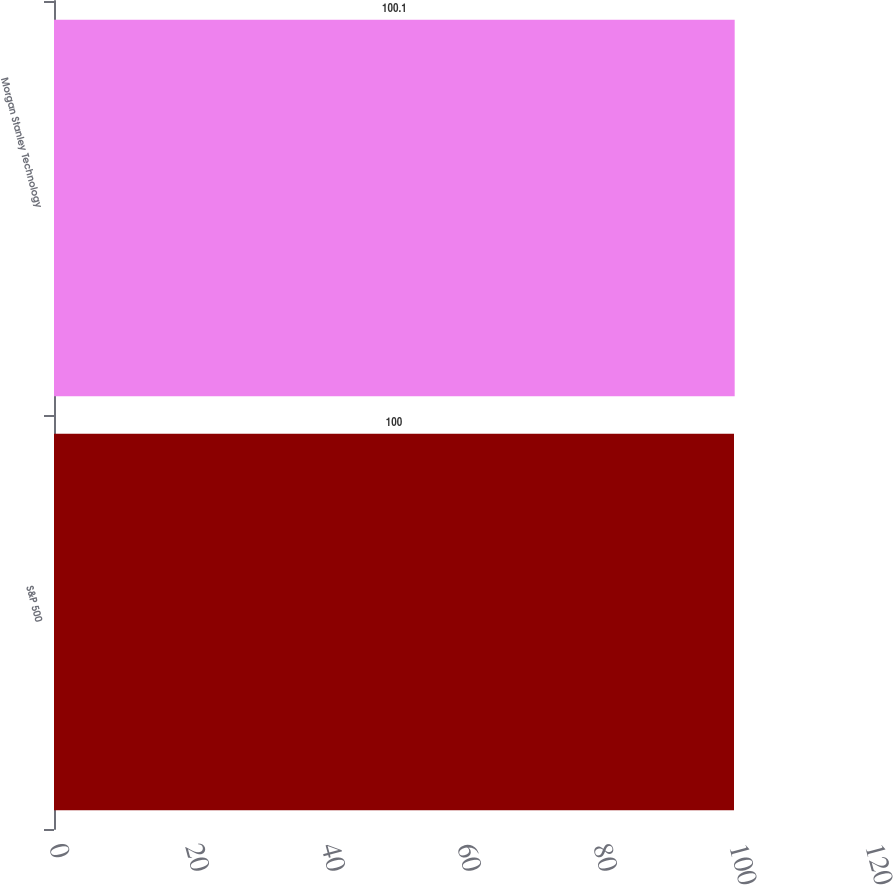Convert chart. <chart><loc_0><loc_0><loc_500><loc_500><bar_chart><fcel>S&P 500<fcel>Morgan Stanley Technology<nl><fcel>100<fcel>100.1<nl></chart> 